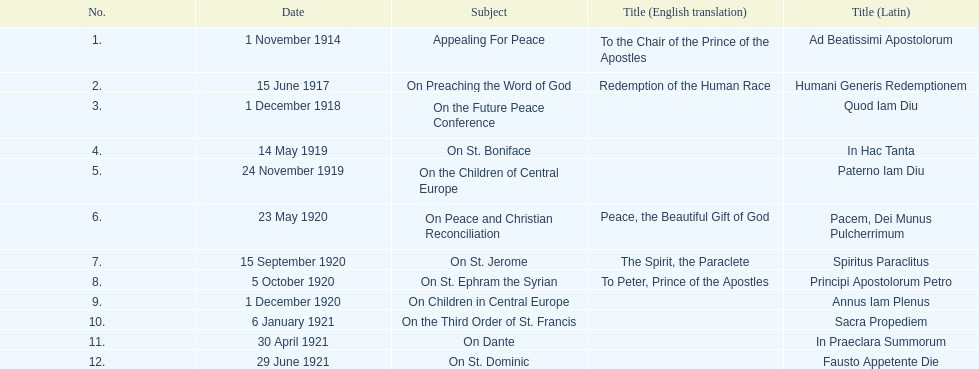What is the subject listed after appealing for peace? On Preaching the Word of God. 